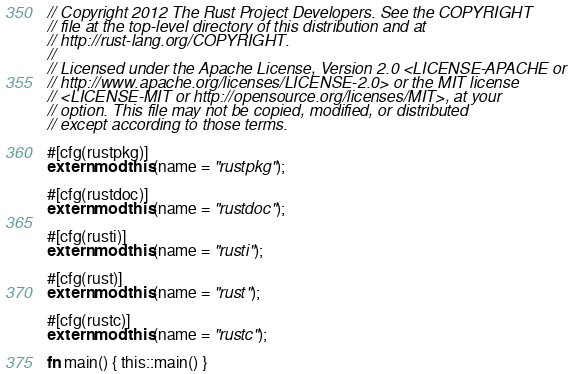<code> <loc_0><loc_0><loc_500><loc_500><_Rust_>// Copyright 2012 The Rust Project Developers. See the COPYRIGHT
// file at the top-level directory of this distribution and at
// http://rust-lang.org/COPYRIGHT.
//
// Licensed under the Apache License, Version 2.0 <LICENSE-APACHE or
// http://www.apache.org/licenses/LICENSE-2.0> or the MIT license
// <LICENSE-MIT or http://opensource.org/licenses/MIT>, at your
// option. This file may not be copied, modified, or distributed
// except according to those terms.

#[cfg(rustpkg)]
extern mod this(name = "rustpkg");

#[cfg(rustdoc)]
extern mod this(name = "rustdoc");

#[cfg(rusti)]
extern mod this(name = "rusti");

#[cfg(rust)]
extern mod this(name = "rust");

#[cfg(rustc)]
extern mod this(name = "rustc");

fn main() { this::main() }
</code> 